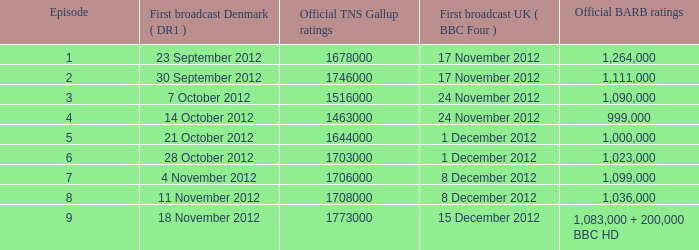Could you parse the entire table? {'header': ['Episode', 'First broadcast Denmark ( DR1 )', 'Official TNS Gallup ratings', 'First broadcast UK ( BBC Four )', 'Official BARB ratings'], 'rows': [['1', '23 September 2012', '1678000', '17 November 2012', '1,264,000'], ['2', '30 September 2012', '1746000', '17 November 2012', '1,111,000'], ['3', '7 October 2012', '1516000', '24 November 2012', '1,090,000'], ['4', '14 October 2012', '1463000', '24 November 2012', '999,000'], ['5', '21 October 2012', '1644000', '1 December 2012', '1,000,000'], ['6', '28 October 2012', '1703000', '1 December 2012', '1,023,000'], ['7', '4 November 2012', '1706000', '8 December 2012', '1,099,000'], ['8', '11 November 2012', '1708000', '8 December 2012', '1,036,000'], ['9', '18 November 2012', '1773000', '15 December 2012', '1,083,000 + 200,000 BBC HD']]} What is the barb viewership of episode 6? 1023000.0. 